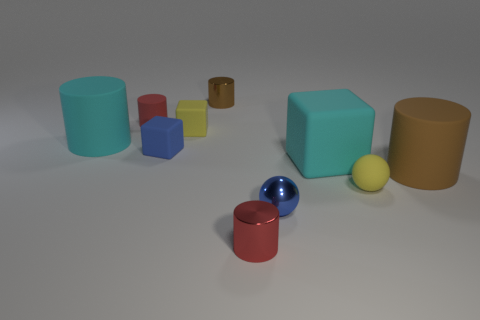There is a large cube; what number of blue cubes are behind it?
Your answer should be very brief. 1. There is a cylinder that is both in front of the blue block and behind the tiny matte sphere; what is it made of?
Provide a succinct answer. Rubber. What number of brown metallic cylinders are the same size as the yellow sphere?
Keep it short and to the point. 1. The big cylinder that is to the left of the small red cylinder in front of the tiny yellow matte ball is what color?
Provide a succinct answer. Cyan. Are there any blue matte balls?
Make the answer very short. No. Is the shape of the small brown thing the same as the tiny blue rubber thing?
Make the answer very short. No. The thing that is the same color as the metal sphere is what size?
Ensure brevity in your answer.  Small. How many metal cylinders are behind the big cylinder on the left side of the large brown cylinder?
Provide a succinct answer. 1. How many large matte things are both on the right side of the red matte cylinder and on the left side of the big cyan block?
Your answer should be very brief. 0. How many objects are either big cyan things or small red objects behind the blue metal sphere?
Give a very brief answer. 3. 